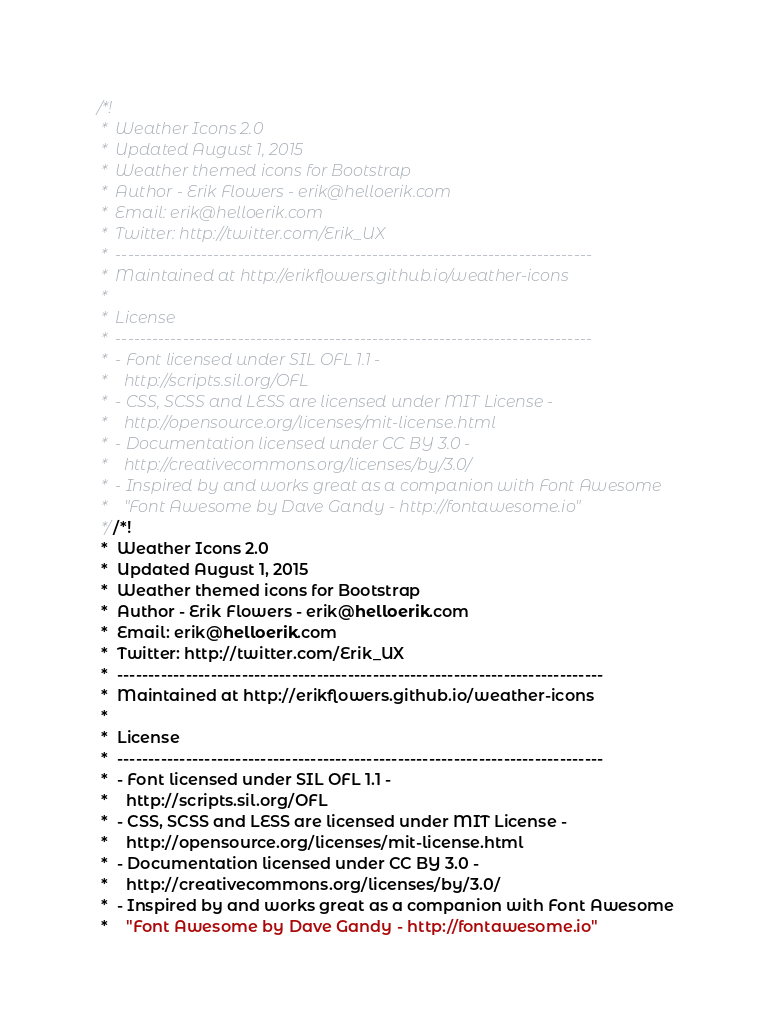<code> <loc_0><loc_0><loc_500><loc_500><_CSS_>/*!
 *  Weather Icons 2.0
 *  Updated August 1, 2015
 *  Weather themed icons for Bootstrap
 *  Author - Erik Flowers - erik@helloerik.com
 *  Email: erik@helloerik.com
 *  Twitter: http://twitter.com/Erik_UX
 *  ------------------------------------------------------------------------------
 *  Maintained at http://erikflowers.github.io/weather-icons
 *
 *  License
 *  ------------------------------------------------------------------------------
 *  - Font licensed under SIL OFL 1.1 -
 *    http://scripts.sil.org/OFL
 *  - CSS, SCSS and LESS are licensed under MIT License -
 *    http://opensource.org/licenses/mit-license.html
 *  - Documentation licensed under CC BY 3.0 -
 *    http://creativecommons.org/licenses/by/3.0/
 *  - Inspired by and works great as a companion with Font Awesome
 *    "Font Awesome by Dave Gandy - http://fontawesome.io"
 *//*!
 *  Weather Icons 2.0
 *  Updated August 1, 2015
 *  Weather themed icons for Bootstrap
 *  Author - Erik Flowers - erik@helloerik.com
 *  Email: erik@helloerik.com
 *  Twitter: http://twitter.com/Erik_UX
 *  ------------------------------------------------------------------------------
 *  Maintained at http://erikflowers.github.io/weather-icons
 *
 *  License
 *  ------------------------------------------------------------------------------
 *  - Font licensed under SIL OFL 1.1 -
 *    http://scripts.sil.org/OFL
 *  - CSS, SCSS and LESS are licensed under MIT License -
 *    http://opensource.org/licenses/mit-license.html
 *  - Documentation licensed under CC BY 3.0 -
 *    http://creativecommons.org/licenses/by/3.0/
 *  - Inspired by and works great as a companion with Font Awesome
 *    "Font Awesome by Dave Gandy - http://fontawesome.io"</code> 